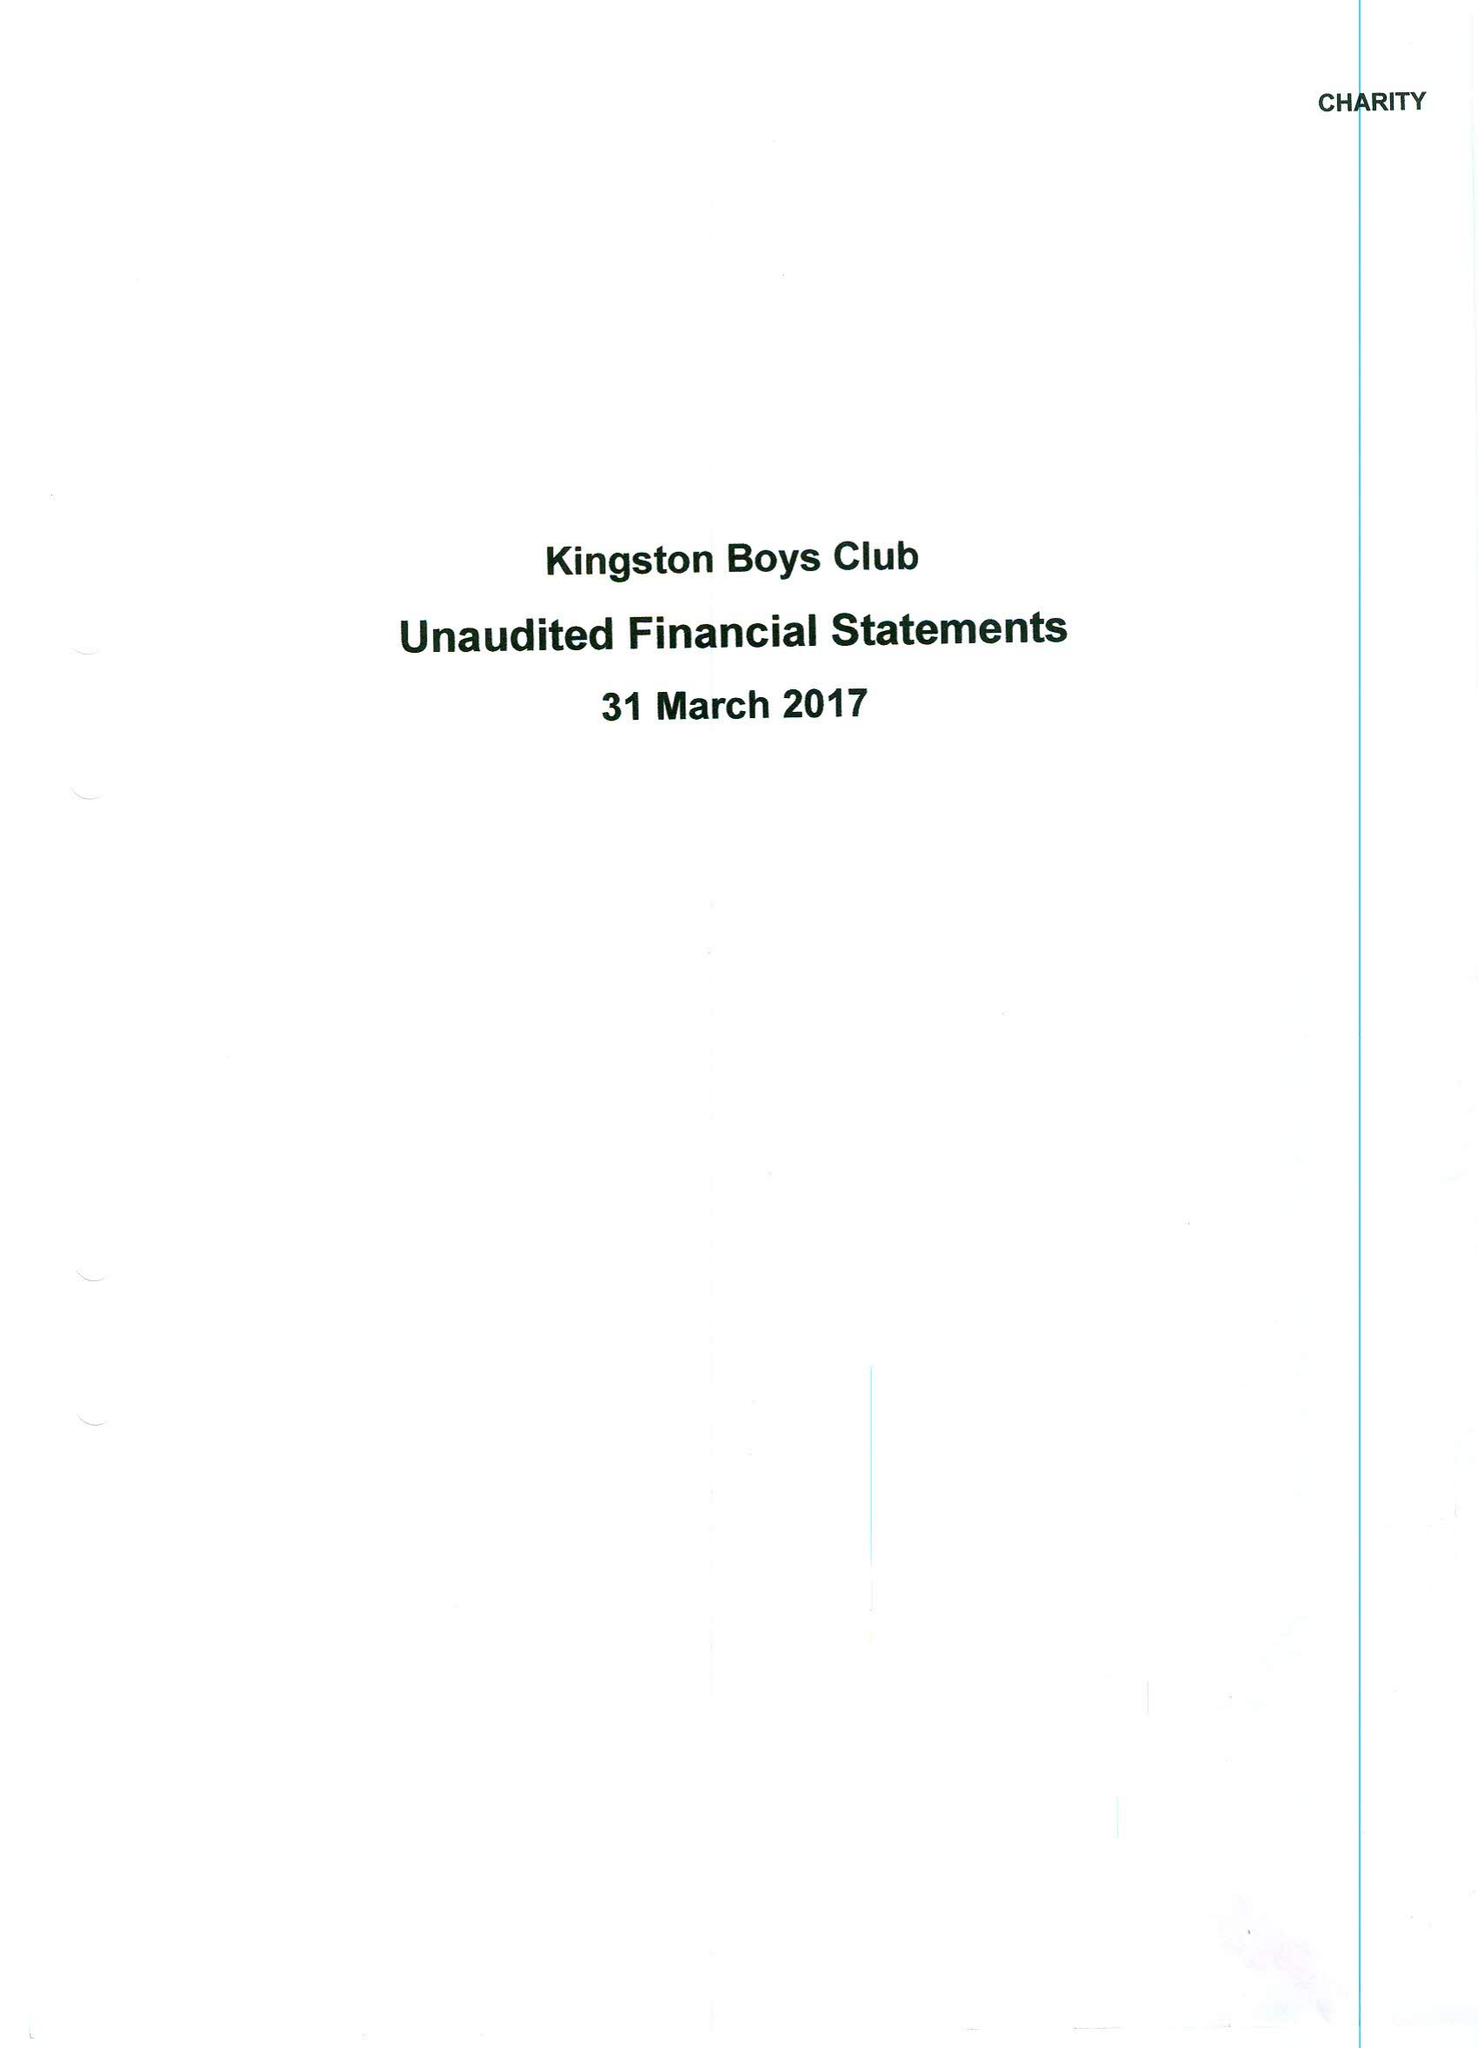What is the value for the address__postcode?
Answer the question using a single word or phrase. KT1 1QY 